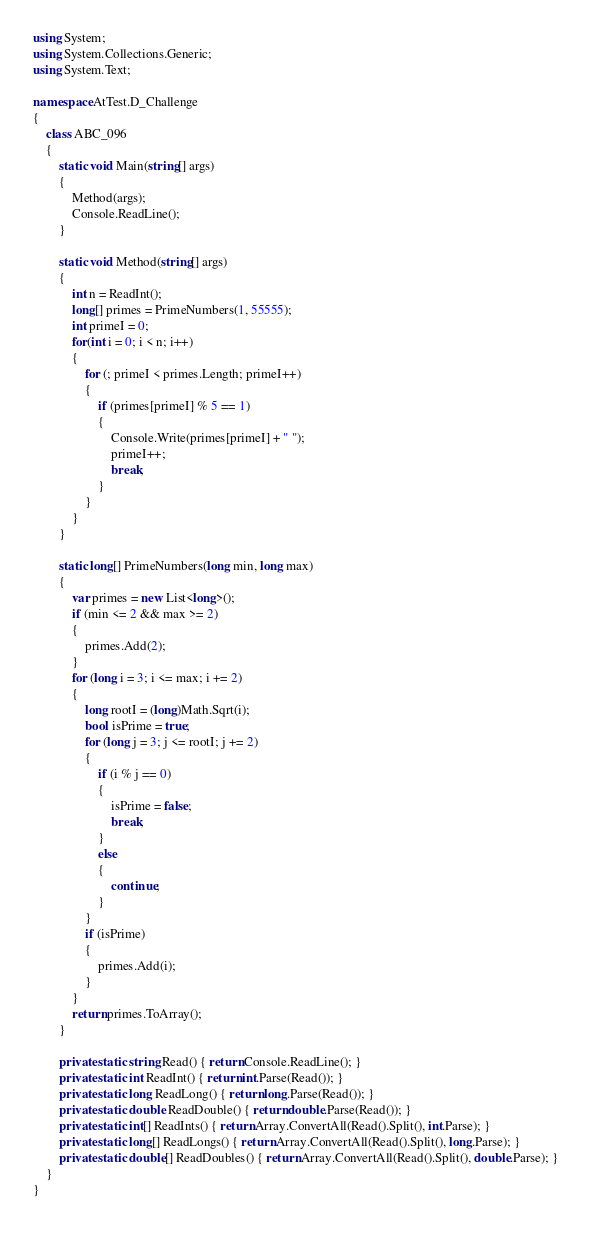Convert code to text. <code><loc_0><loc_0><loc_500><loc_500><_C#_>using System;
using System.Collections.Generic;
using System.Text;

namespace AtTest.D_Challenge
{
    class ABC_096
    {
        static void Main(string[] args)
        {
            Method(args);
            Console.ReadLine();
        }

        static void Method(string[] args)
        {
            int n = ReadInt();
            long[] primes = PrimeNumbers(1, 55555);
            int primeI = 0;
            for(int i = 0; i < n; i++)
            {
                for (; primeI < primes.Length; primeI++)
                {
                    if (primes[primeI] % 5 == 1)
                    {
                        Console.Write(primes[primeI] + " ");
                        primeI++;
                        break;
                    }
                }
            }
        }

        static long[] PrimeNumbers(long min, long max)
        {
            var primes = new List<long>();
            if (min <= 2 && max >= 2)
            {
                primes.Add(2);
            }
            for (long i = 3; i <= max; i += 2)
            {
                long rootI = (long)Math.Sqrt(i);
                bool isPrime = true;
                for (long j = 3; j <= rootI; j += 2)
                {
                    if (i % j == 0)
                    {
                        isPrime = false;
                        break;
                    }
                    else
                    {
                        continue;
                    }
                }
                if (isPrime)
                {
                    primes.Add(i);
                }
            }
            return primes.ToArray();
        }

        private static string Read() { return Console.ReadLine(); }
        private static int ReadInt() { return int.Parse(Read()); }
        private static long ReadLong() { return long.Parse(Read()); }
        private static double ReadDouble() { return double.Parse(Read()); }
        private static int[] ReadInts() { return Array.ConvertAll(Read().Split(), int.Parse); }
        private static long[] ReadLongs() { return Array.ConvertAll(Read().Split(), long.Parse); }
        private static double[] ReadDoubles() { return Array.ConvertAll(Read().Split(), double.Parse); }
    }
}
</code> 